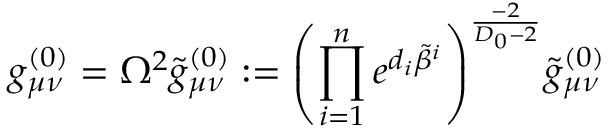<formula> <loc_0><loc_0><loc_500><loc_500>g _ { \mu \nu } ^ { ( 0 ) } = \Omega ^ { 2 } \tilde { g } _ { \mu \nu } ^ { ( 0 ) } \colon = { \left ( \prod _ { i = 1 } ^ { n } e ^ { d _ { i } \tilde { \beta } ^ { i } } \right ) } ^ { \frac { - 2 } { D _ { 0 } - 2 } } \tilde { g } _ { \mu \nu } ^ { ( 0 ) }</formula> 